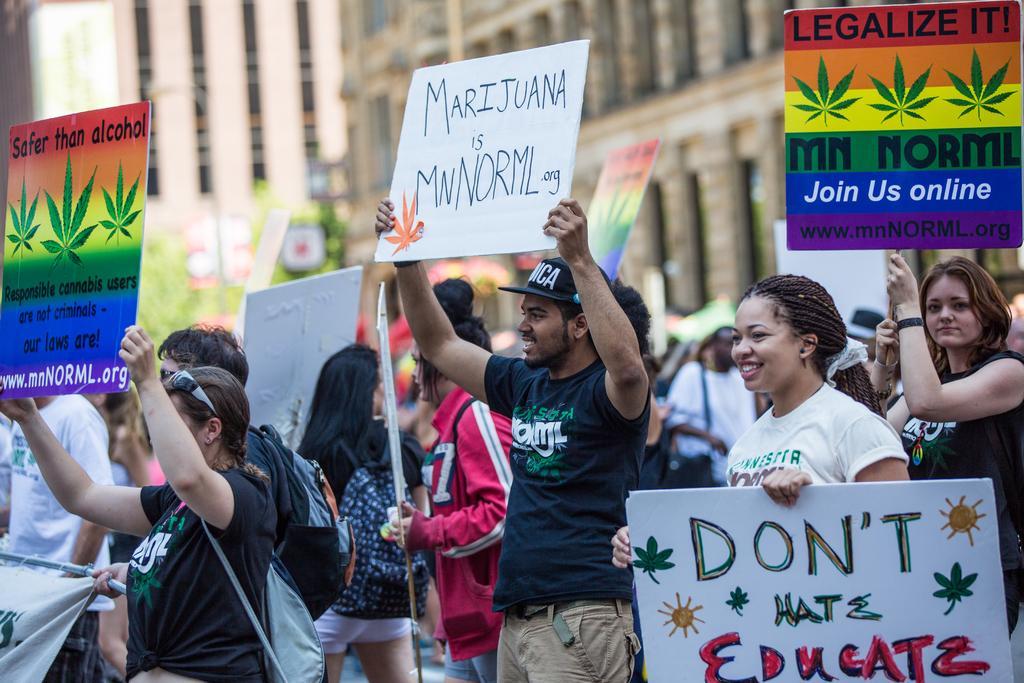Describe this image in one or two sentences. This picture is clicked outside. In the foreground we can see the group of people standing on the ground and holding banners on which we can see the text is written and printed. In the background we can see the buildings and some trees. 